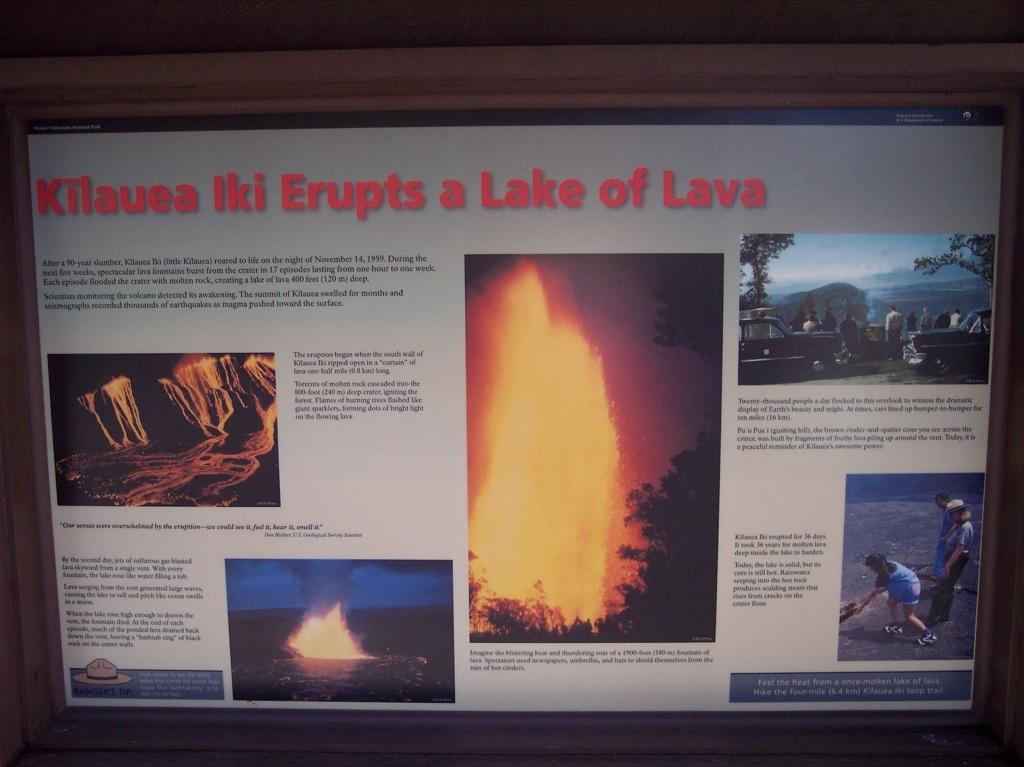What is the main object in the image? There is a monitor in the image. What is displayed on the monitor's screen? The monitor's screen displays a fire, a group of people, cars, and water. Is there any text on the monitor's screen? Yes, there is text written on the monitor's screen. Where is the patch of grass located in the image? There is no patch of grass present in the image; it only features a monitor with various images and text on its screen. Can you see any children playing on the playground in the image? There is no playground or children present in the image; it only features a monitor with various images and text on its screen. 